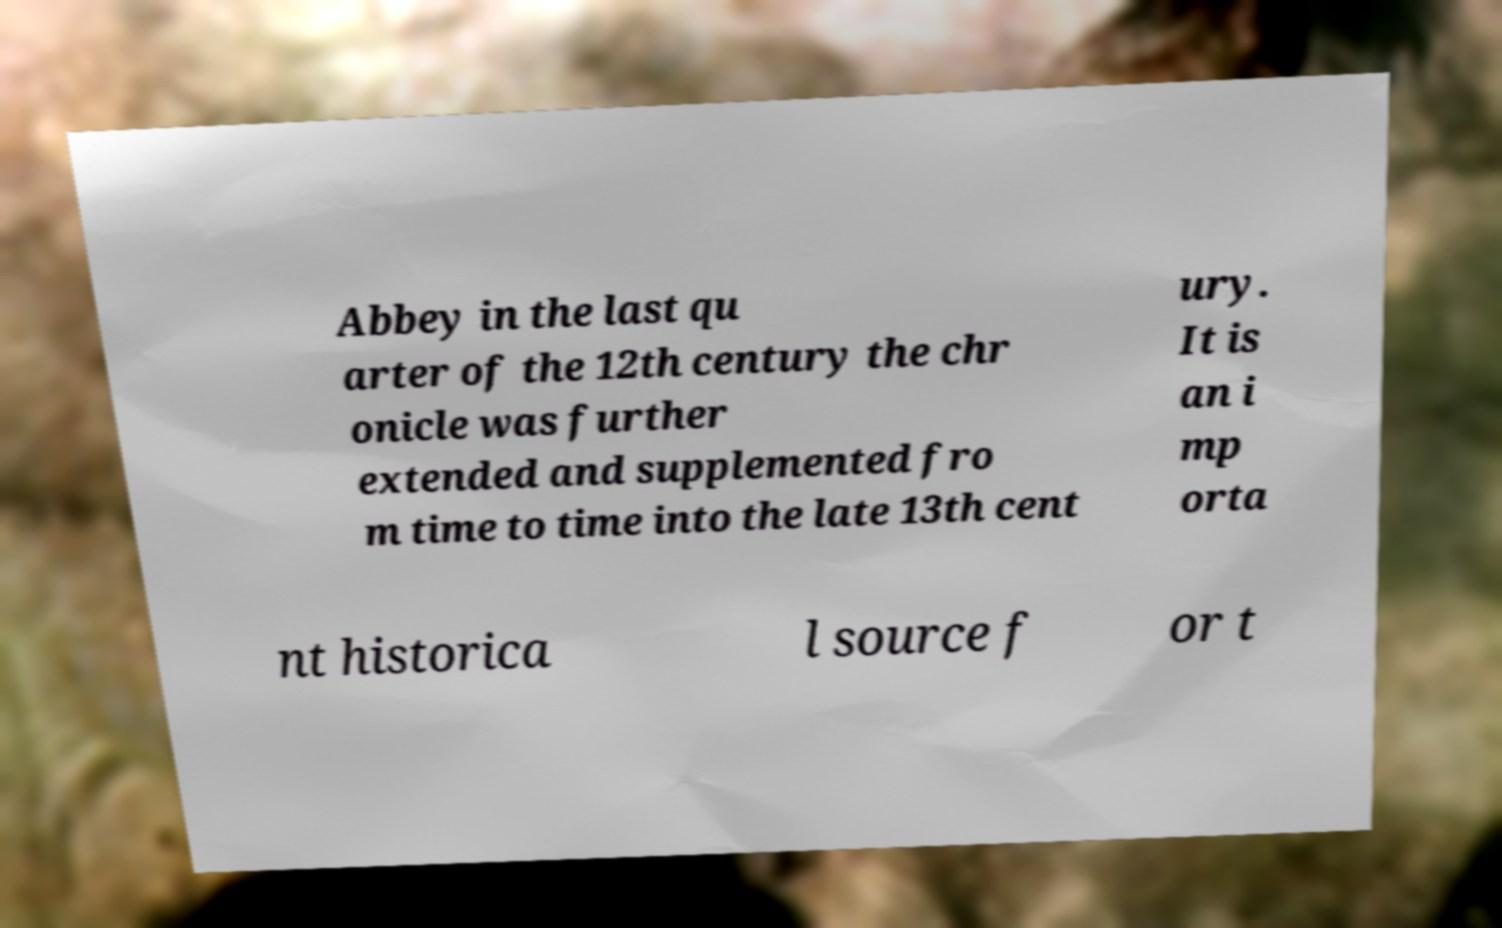Please identify and transcribe the text found in this image. Abbey in the last qu arter of the 12th century the chr onicle was further extended and supplemented fro m time to time into the late 13th cent ury. It is an i mp orta nt historica l source f or t 